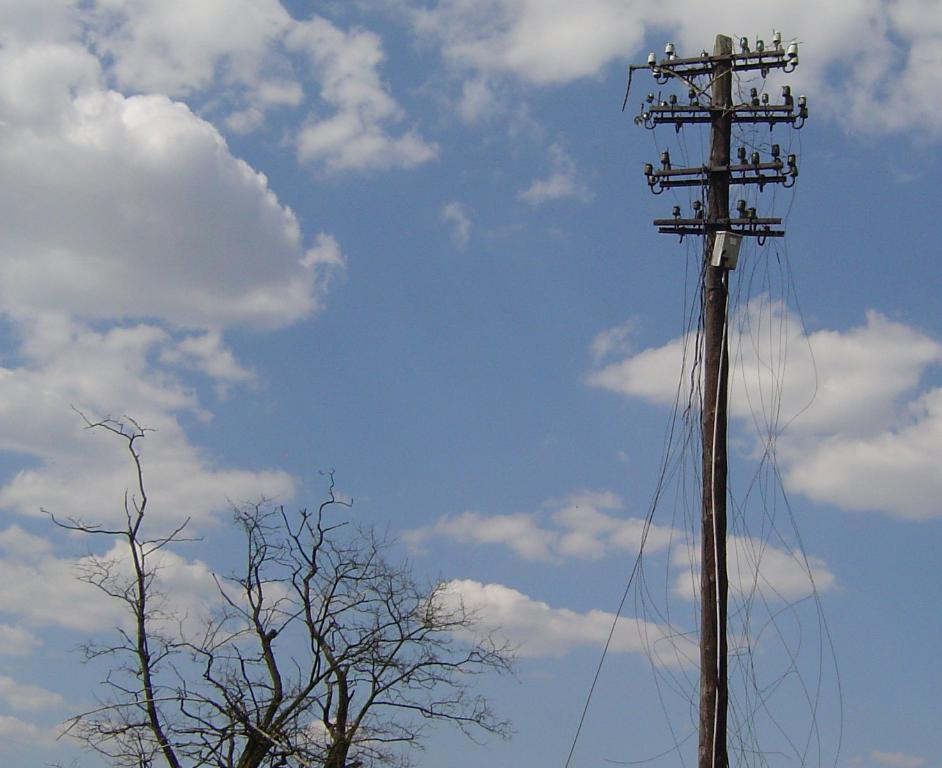What type of natural element can be seen in the image? There is a tree in the image. What man-made structure is present in the image? There is a pole with wires in the image. How are the wires connected to the pole? The wires are fixed to the pole. What can be seen in the sky at the top of the image? There are clouds in the sky at the top of the image. What type of error can be seen in the image? There is no error present in the image. What angle is the tree leaning at in the image? The angle of the tree cannot be determined from the image, as it appears to be standing upright. 